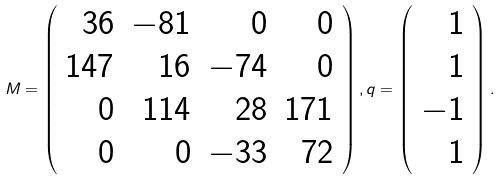Convert formula to latex. <formula><loc_0><loc_0><loc_500><loc_500>M = \left ( \begin{array} { r r r r } 3 6 & - 8 1 & 0 & 0 \\ 1 4 7 & 1 6 & - 7 4 & 0 \\ 0 & 1 1 4 & 2 8 & 1 7 1 \\ 0 & 0 & - 3 3 & 7 2 \end{array} \right ) , q = \left ( \begin{array} { r } 1 \\ 1 \\ - 1 \\ 1 \end{array} \right ) .</formula> 